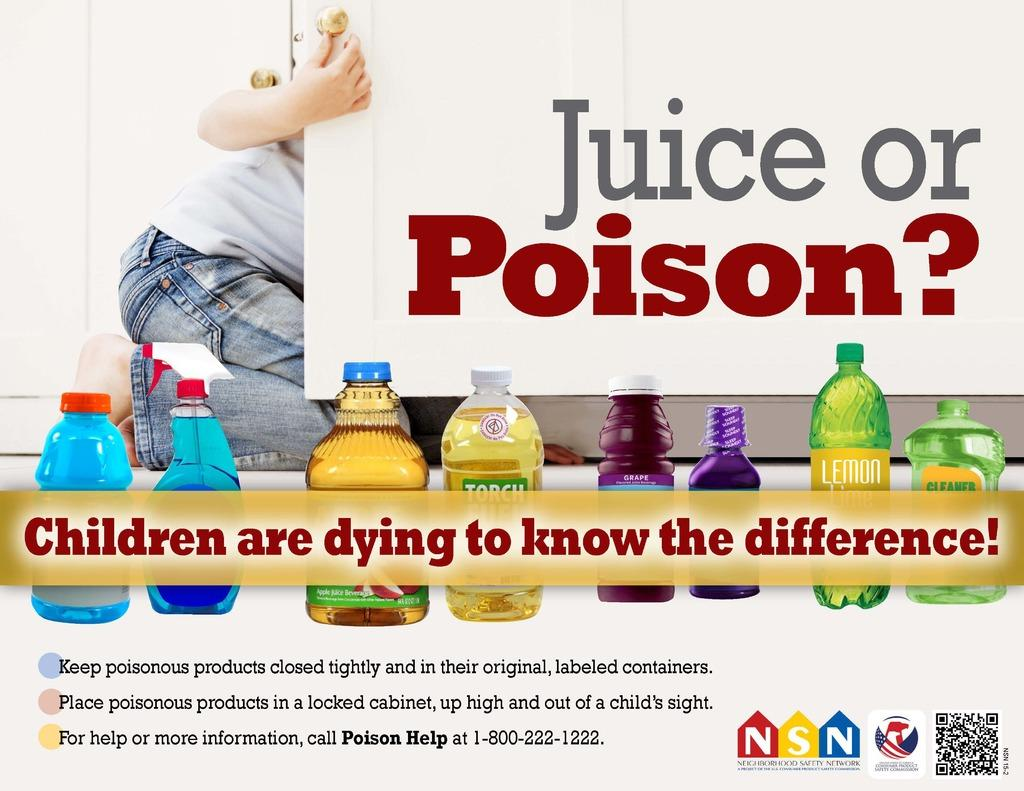<image>
Describe the image concisely. A poster that discusses how to keep children safe from dangerous substances. 